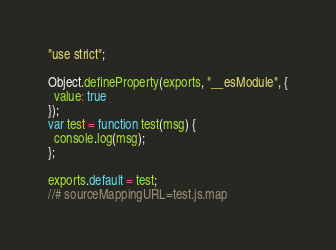Convert code to text. <code><loc_0><loc_0><loc_500><loc_500><_JavaScript_>"use strict";

Object.defineProperty(exports, "__esModule", {
  value: true
});
var test = function test(msg) {
  console.log(msg);
};

exports.default = test;
//# sourceMappingURL=test.js.map</code> 